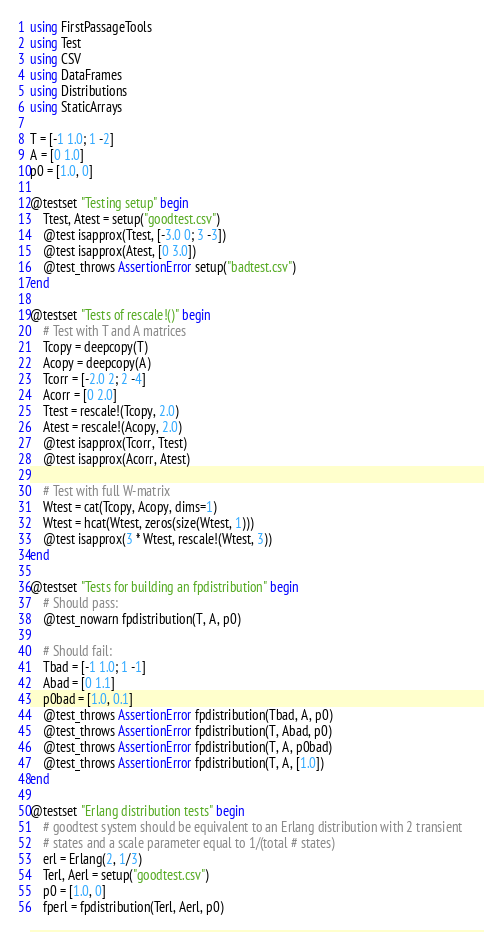Convert code to text. <code><loc_0><loc_0><loc_500><loc_500><_Julia_>using FirstPassageTools
using Test
using CSV
using DataFrames
using Distributions
using StaticArrays

T = [-1 1.0; 1 -2]
A = [0 1.0]
p0 = [1.0, 0]

@testset "Testing setup" begin
    Ttest, Atest = setup("goodtest.csv")
    @test isapprox(Ttest, [-3.0 0; 3 -3])
    @test isapprox(Atest, [0 3.0])
    @test_throws AssertionError setup("badtest.csv")
end

@testset "Tests of rescale!()" begin
    # Test with T and A matrices
    Tcopy = deepcopy(T)
    Acopy = deepcopy(A)
    Tcorr = [-2.0 2; 2 -4]
    Acorr = [0 2.0]
    Ttest = rescale!(Tcopy, 2.0)
    Atest = rescale!(Acopy, 2.0)
    @test isapprox(Tcorr, Ttest)
    @test isapprox(Acorr, Atest)

    # Test with full W-matrix
    Wtest = cat(Tcopy, Acopy, dims=1)
    Wtest = hcat(Wtest, zeros(size(Wtest, 1)))
    @test isapprox(3 * Wtest, rescale!(Wtest, 3))
end

@testset "Tests for building an fpdistribution" begin
    # Should pass:
    @test_nowarn fpdistribution(T, A, p0)
    
    # Should fail:
    Tbad = [-1 1.0; 1 -1]
    Abad = [0 1.1]
    p0bad = [1.0, 0.1]
    @test_throws AssertionError fpdistribution(Tbad, A, p0)
    @test_throws AssertionError fpdistribution(T, Abad, p0)
    @test_throws AssertionError fpdistribution(T, A, p0bad)
    @test_throws AssertionError fpdistribution(T, A, [1.0])
end

@testset "Erlang distribution tests" begin
    # goodtest system should be equivalent to an Erlang distribution with 2 transient 
    # states and a scale parameter equal to 1/(total # states)
    erl = Erlang(2, 1/3)
    Terl, Aerl = setup("goodtest.csv")
    p0 = [1.0, 0]
    fperl = fpdistribution(Terl, Aerl, p0)</code> 